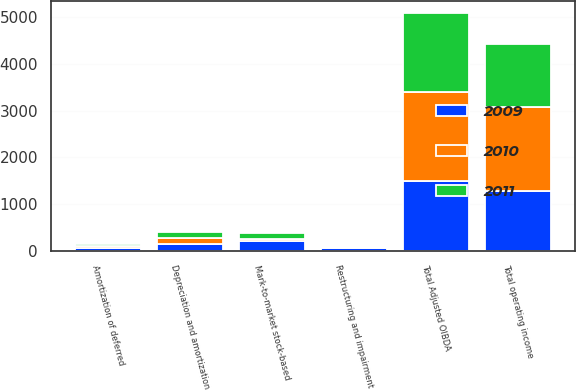<chart> <loc_0><loc_0><loc_500><loc_500><stacked_bar_chart><ecel><fcel>Total Adjusted OIBDA<fcel>Amortization of deferred<fcel>Mark-to-market stock-based<fcel>Depreciation and amortization<fcel>Restructuring and impairment<fcel>Total operating income<nl><fcel>2010<fcel>1914<fcel>52<fcel>43<fcel>119<fcel>30<fcel>1799<nl><fcel>2011<fcel>1699<fcel>42<fcel>142<fcel>130<fcel>25<fcel>1360<nl><fcel>2009<fcel>1486<fcel>55<fcel>205<fcel>152<fcel>52<fcel>1274<nl></chart> 